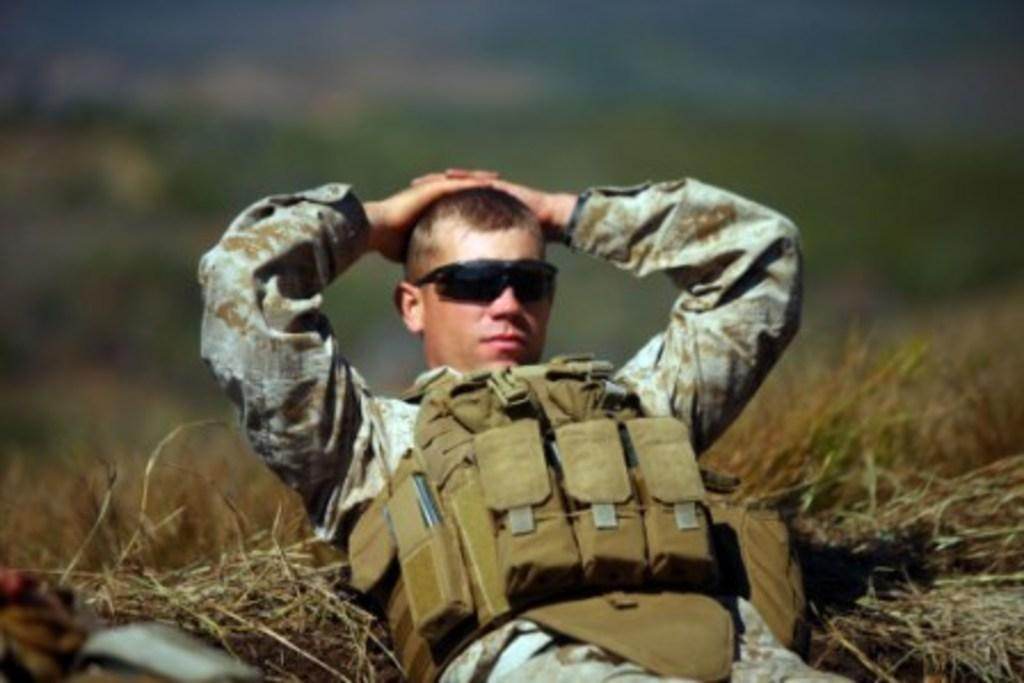What is the main subject of the image? There is a person lying on the grass in the image. Can you describe the background of the image? The background of the image is blurred. How many girls are twisting on the spot in the image? There are no girls present in the image, and no one is twisting on the spot. 